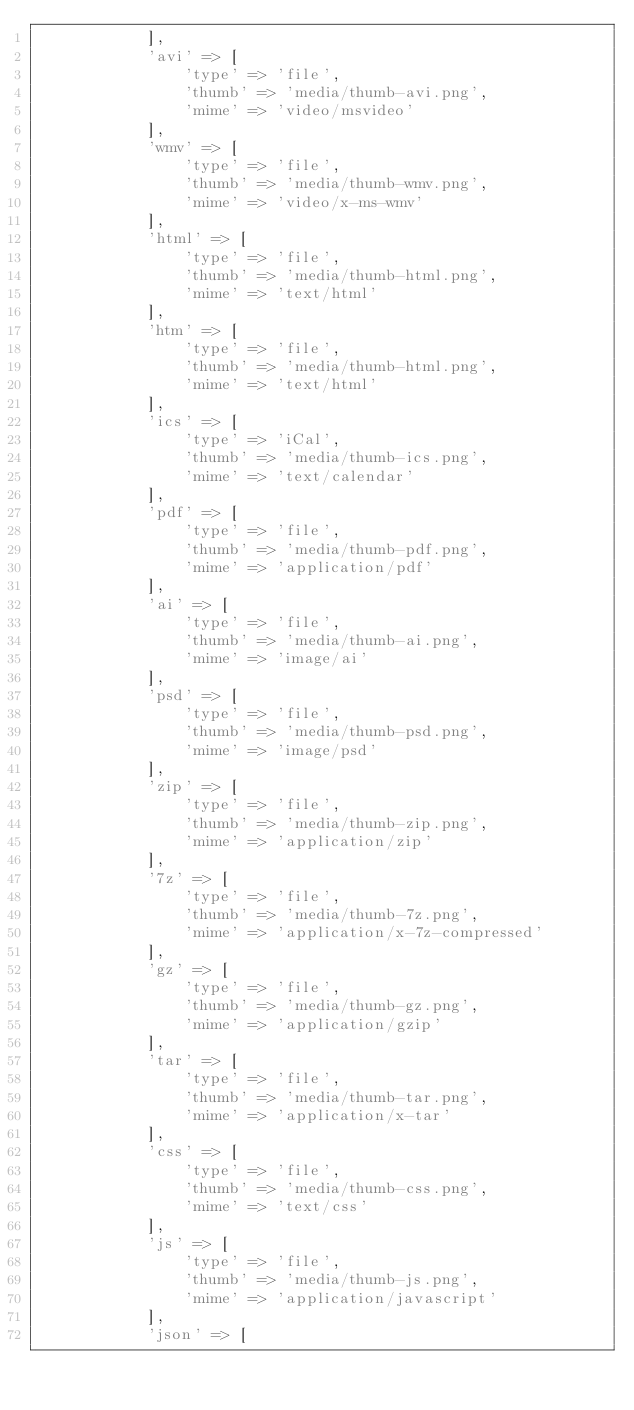Convert code to text. <code><loc_0><loc_0><loc_500><loc_500><_PHP_>            ],
            'avi' => [
                'type' => 'file',
                'thumb' => 'media/thumb-avi.png',
                'mime' => 'video/msvideo'
            ],
            'wmv' => [
                'type' => 'file',
                'thumb' => 'media/thumb-wmv.png',
                'mime' => 'video/x-ms-wmv'
            ],
            'html' => [
                'type' => 'file',
                'thumb' => 'media/thumb-html.png',
                'mime' => 'text/html'
            ],
            'htm' => [
                'type' => 'file',
                'thumb' => 'media/thumb-html.png',
                'mime' => 'text/html'
            ],
            'ics' => [
                'type' => 'iCal',
                'thumb' => 'media/thumb-ics.png',
                'mime' => 'text/calendar'
            ],
            'pdf' => [
                'type' => 'file',
                'thumb' => 'media/thumb-pdf.png',
                'mime' => 'application/pdf'
            ],
            'ai' => [
                'type' => 'file',
                'thumb' => 'media/thumb-ai.png',
                'mime' => 'image/ai'
            ],
            'psd' => [
                'type' => 'file',
                'thumb' => 'media/thumb-psd.png',
                'mime' => 'image/psd'
            ],
            'zip' => [
                'type' => 'file',
                'thumb' => 'media/thumb-zip.png',
                'mime' => 'application/zip'
            ],
            '7z' => [
                'type' => 'file',
                'thumb' => 'media/thumb-7z.png',
                'mime' => 'application/x-7z-compressed'
            ],
            'gz' => [
                'type' => 'file',
                'thumb' => 'media/thumb-gz.png',
                'mime' => 'application/gzip'
            ],
            'tar' => [
                'type' => 'file',
                'thumb' => 'media/thumb-tar.png',
                'mime' => 'application/x-tar'
            ],
            'css' => [
                'type' => 'file',
                'thumb' => 'media/thumb-css.png',
                'mime' => 'text/css'
            ],
            'js' => [
                'type' => 'file',
                'thumb' => 'media/thumb-js.png',
                'mime' => 'application/javascript'
            ],
            'json' => [</code> 